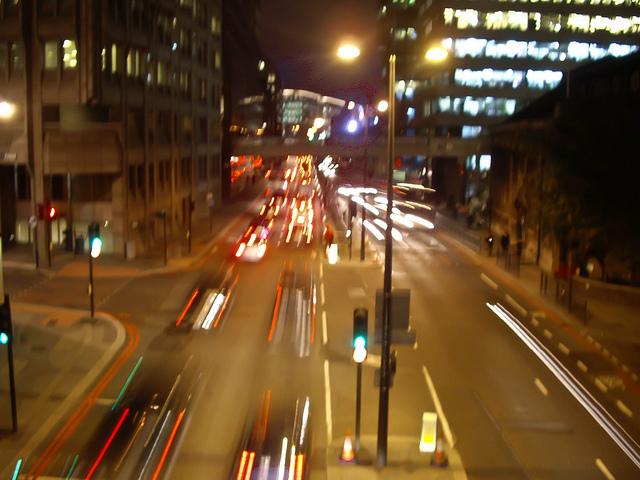What are the cars blurry?
Answer briefly. Yes. Is this a one way street?
Write a very short answer. No. Are there many cars on the street?
Short answer required. Yes. 